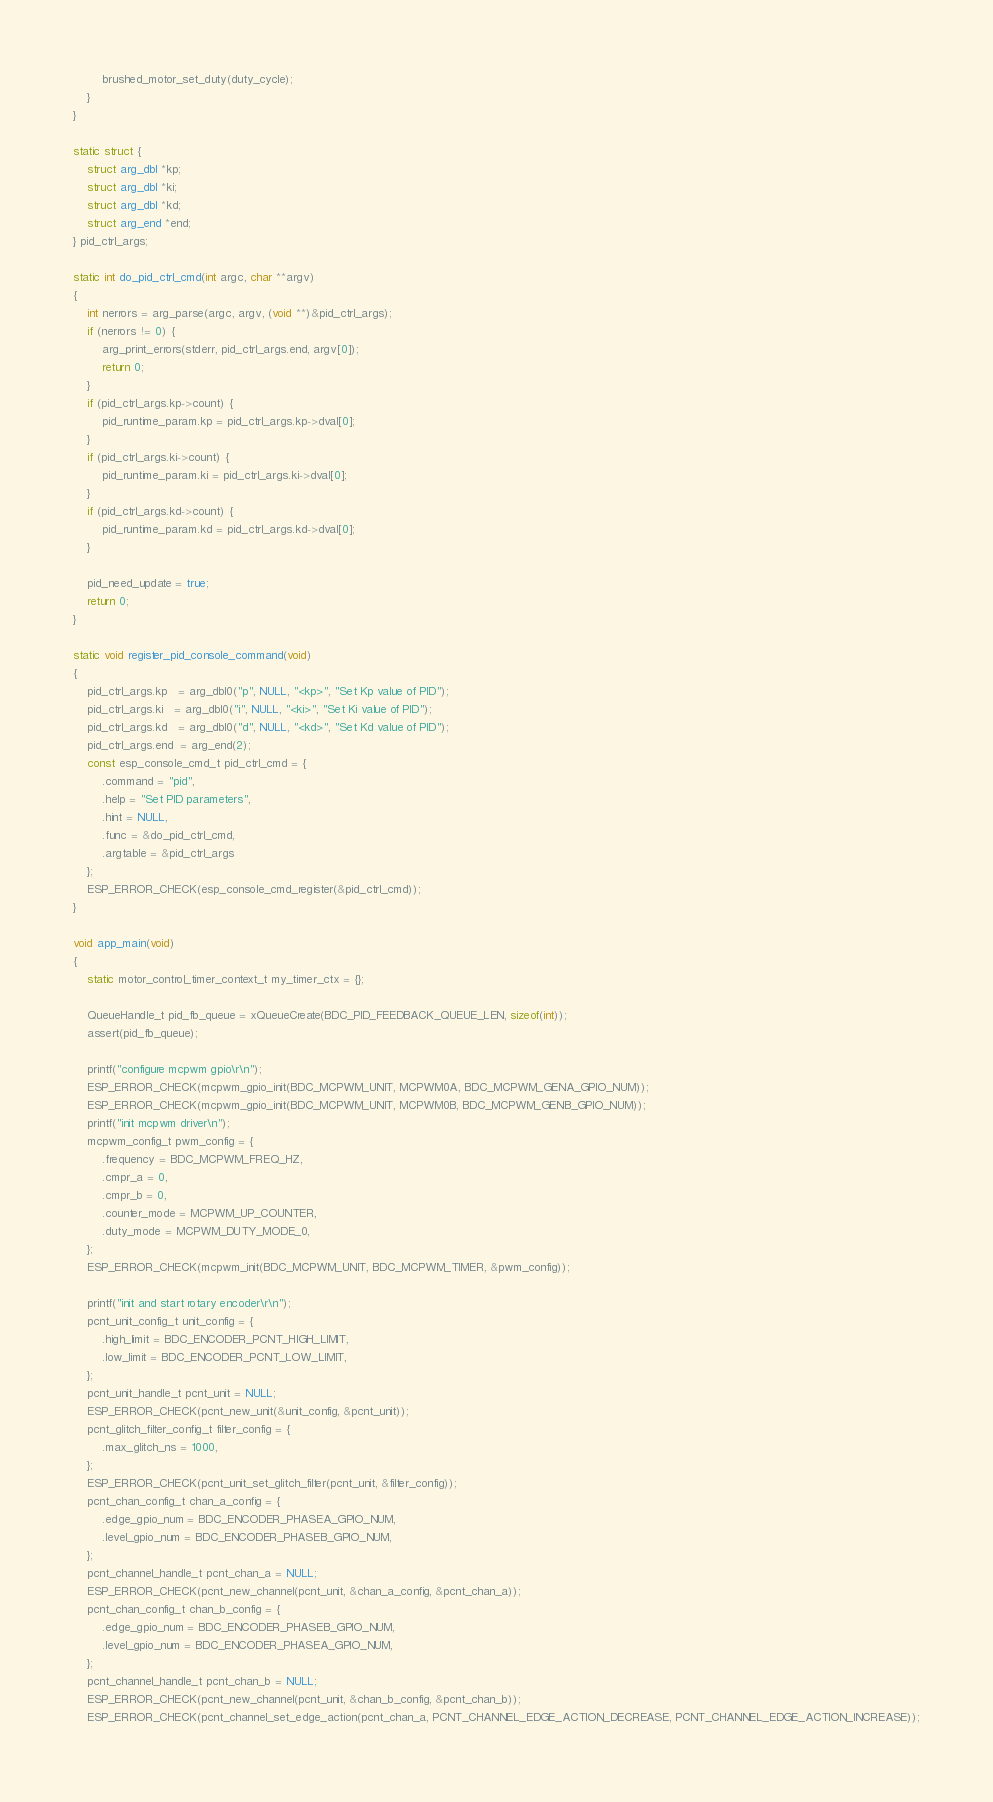Convert code to text. <code><loc_0><loc_0><loc_500><loc_500><_C_>        brushed_motor_set_duty(duty_cycle);
    }
}

static struct {
    struct arg_dbl *kp;
    struct arg_dbl *ki;
    struct arg_dbl *kd;
    struct arg_end *end;
} pid_ctrl_args;

static int do_pid_ctrl_cmd(int argc, char **argv)
{
    int nerrors = arg_parse(argc, argv, (void **)&pid_ctrl_args);
    if (nerrors != 0) {
        arg_print_errors(stderr, pid_ctrl_args.end, argv[0]);
        return 0;
    }
    if (pid_ctrl_args.kp->count) {
        pid_runtime_param.kp = pid_ctrl_args.kp->dval[0];
    }
    if (pid_ctrl_args.ki->count) {
        pid_runtime_param.ki = pid_ctrl_args.ki->dval[0];
    }
    if (pid_ctrl_args.kd->count) {
        pid_runtime_param.kd = pid_ctrl_args.kd->dval[0];
    }

    pid_need_update = true;
    return 0;
}

static void register_pid_console_command(void)
{
    pid_ctrl_args.kp   = arg_dbl0("p", NULL, "<kp>", "Set Kp value of PID");
    pid_ctrl_args.ki   = arg_dbl0("i", NULL, "<ki>", "Set Ki value of PID");
    pid_ctrl_args.kd   = arg_dbl0("d", NULL, "<kd>", "Set Kd value of PID");
    pid_ctrl_args.end  = arg_end(2);
    const esp_console_cmd_t pid_ctrl_cmd = {
        .command = "pid",
        .help = "Set PID parameters",
        .hint = NULL,
        .func = &do_pid_ctrl_cmd,
        .argtable = &pid_ctrl_args
    };
    ESP_ERROR_CHECK(esp_console_cmd_register(&pid_ctrl_cmd));
}

void app_main(void)
{
    static motor_control_timer_context_t my_timer_ctx = {};

    QueueHandle_t pid_fb_queue = xQueueCreate(BDC_PID_FEEDBACK_QUEUE_LEN, sizeof(int));
    assert(pid_fb_queue);

    printf("configure mcpwm gpio\r\n");
    ESP_ERROR_CHECK(mcpwm_gpio_init(BDC_MCPWM_UNIT, MCPWM0A, BDC_MCPWM_GENA_GPIO_NUM));
    ESP_ERROR_CHECK(mcpwm_gpio_init(BDC_MCPWM_UNIT, MCPWM0B, BDC_MCPWM_GENB_GPIO_NUM));
    printf("init mcpwm driver\n");
    mcpwm_config_t pwm_config = {
        .frequency = BDC_MCPWM_FREQ_HZ,
        .cmpr_a = 0,
        .cmpr_b = 0,
        .counter_mode = MCPWM_UP_COUNTER,
        .duty_mode = MCPWM_DUTY_MODE_0,
    };
    ESP_ERROR_CHECK(mcpwm_init(BDC_MCPWM_UNIT, BDC_MCPWM_TIMER, &pwm_config));

    printf("init and start rotary encoder\r\n");
    pcnt_unit_config_t unit_config = {
        .high_limit = BDC_ENCODER_PCNT_HIGH_LIMIT,
        .low_limit = BDC_ENCODER_PCNT_LOW_LIMIT,
    };
    pcnt_unit_handle_t pcnt_unit = NULL;
    ESP_ERROR_CHECK(pcnt_new_unit(&unit_config, &pcnt_unit));
    pcnt_glitch_filter_config_t filter_config = {
        .max_glitch_ns = 1000,
    };
    ESP_ERROR_CHECK(pcnt_unit_set_glitch_filter(pcnt_unit, &filter_config));
    pcnt_chan_config_t chan_a_config = {
        .edge_gpio_num = BDC_ENCODER_PHASEA_GPIO_NUM,
        .level_gpio_num = BDC_ENCODER_PHASEB_GPIO_NUM,
    };
    pcnt_channel_handle_t pcnt_chan_a = NULL;
    ESP_ERROR_CHECK(pcnt_new_channel(pcnt_unit, &chan_a_config, &pcnt_chan_a));
    pcnt_chan_config_t chan_b_config = {
        .edge_gpio_num = BDC_ENCODER_PHASEB_GPIO_NUM,
        .level_gpio_num = BDC_ENCODER_PHASEA_GPIO_NUM,
    };
    pcnt_channel_handle_t pcnt_chan_b = NULL;
    ESP_ERROR_CHECK(pcnt_new_channel(pcnt_unit, &chan_b_config, &pcnt_chan_b));
    ESP_ERROR_CHECK(pcnt_channel_set_edge_action(pcnt_chan_a, PCNT_CHANNEL_EDGE_ACTION_DECREASE, PCNT_CHANNEL_EDGE_ACTION_INCREASE));</code> 